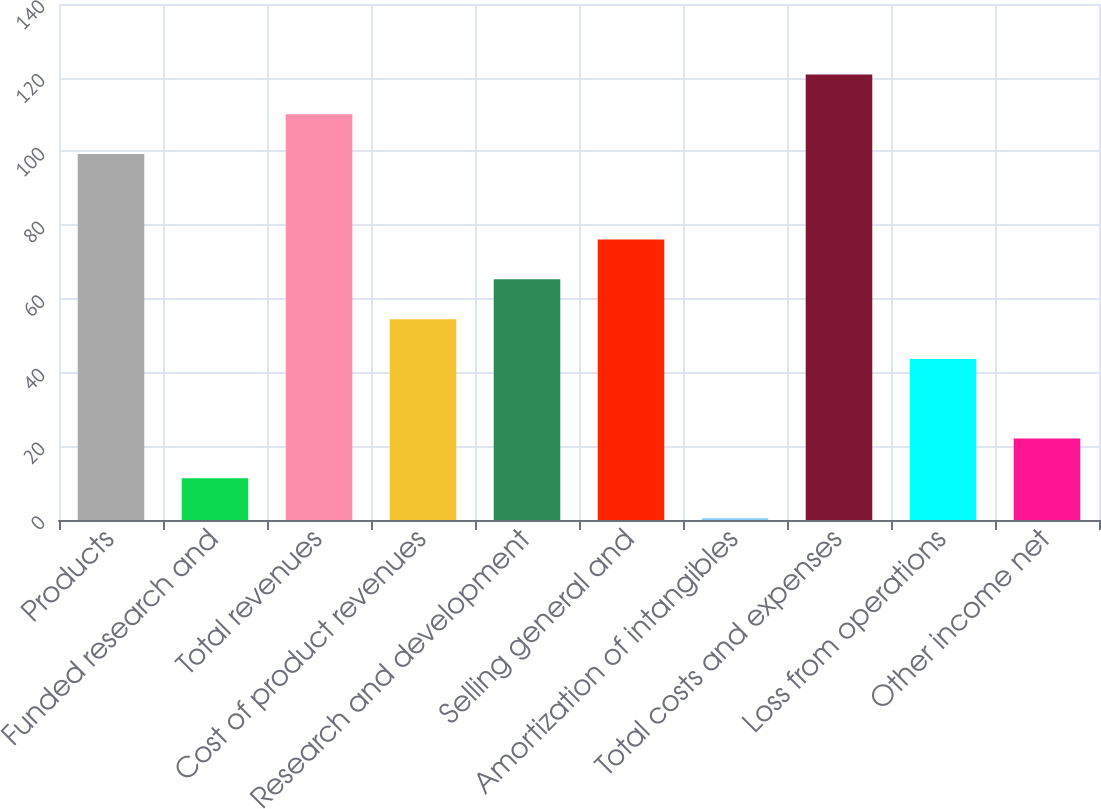Convert chart. <chart><loc_0><loc_0><loc_500><loc_500><bar_chart><fcel>Products<fcel>Funded research and<fcel>Total revenues<fcel>Cost of product revenues<fcel>Research and development<fcel>Selling general and<fcel>Amortization of intangibles<fcel>Total costs and expenses<fcel>Loss from operations<fcel>Other income net<nl><fcel>99.3<fcel>11.3<fcel>110.1<fcel>54.5<fcel>65.3<fcel>76.1<fcel>0.5<fcel>120.9<fcel>43.7<fcel>22.1<nl></chart> 